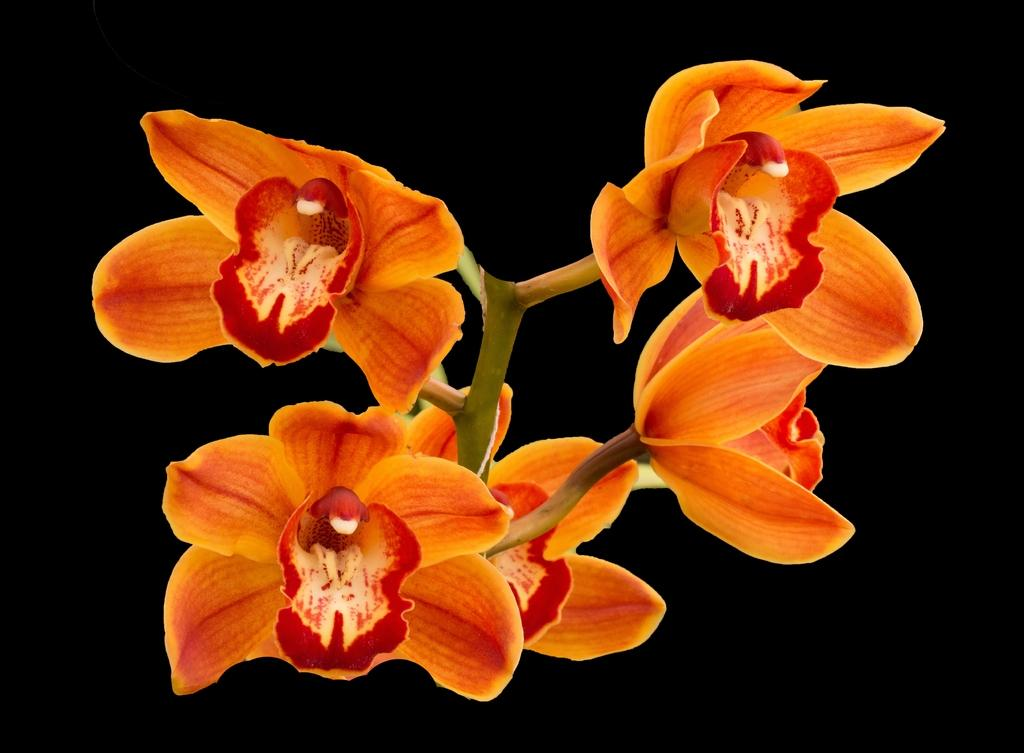What type of plant can be seen in the image? There is a flowering plant in the image. What force is being applied to the plant to change its shape in the image? There is no force being applied to the plant in the image, and its shape remains unchanged. 